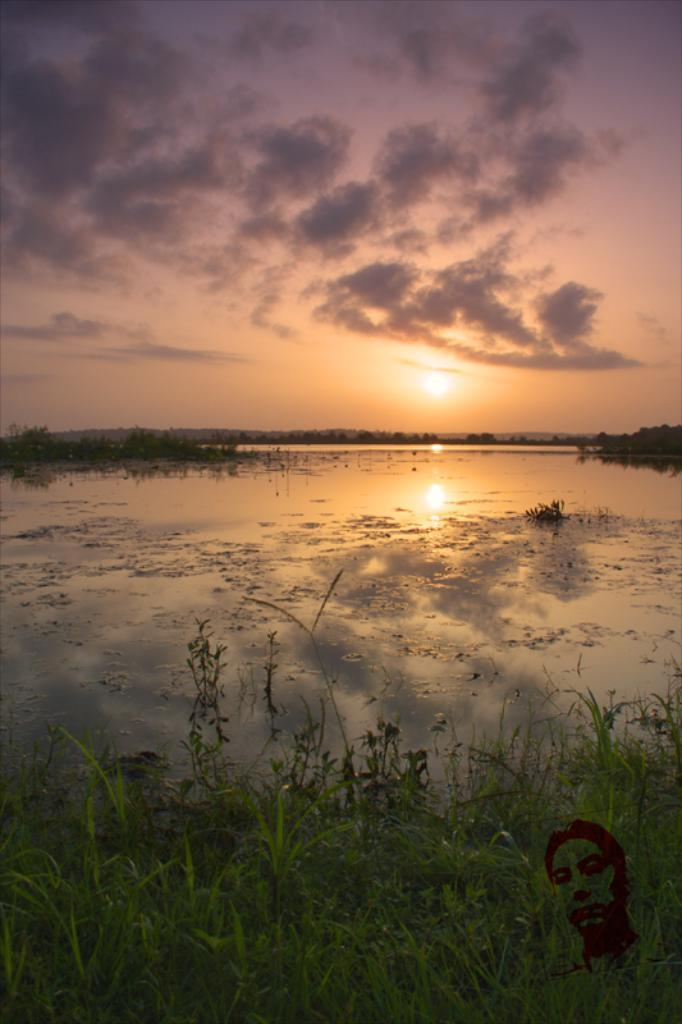What type of vegetation is at the bottom of the image? There is grass present at the bottom of the image. What is located in the center of the image? There is water in the center of the image. What can be seen in the background of the image? The sky, the sun, and clouds are visible in the background of the image. How many ants can be seen climbing the wall in the image? There are no ants or walls present in the image. What action is the wall performing in the image? There is no wall present in the image, so it cannot perform any actions. 